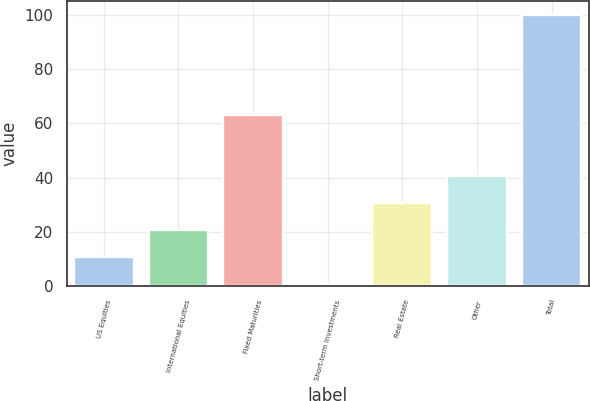Convert chart. <chart><loc_0><loc_0><loc_500><loc_500><bar_chart><fcel>US Equities<fcel>International Equities<fcel>Fixed Maturities<fcel>Short-term Investments<fcel>Real Estate<fcel>Other<fcel>Total<nl><fcel>10.83<fcel>20.74<fcel>63<fcel>0.92<fcel>30.65<fcel>40.56<fcel>100<nl></chart> 